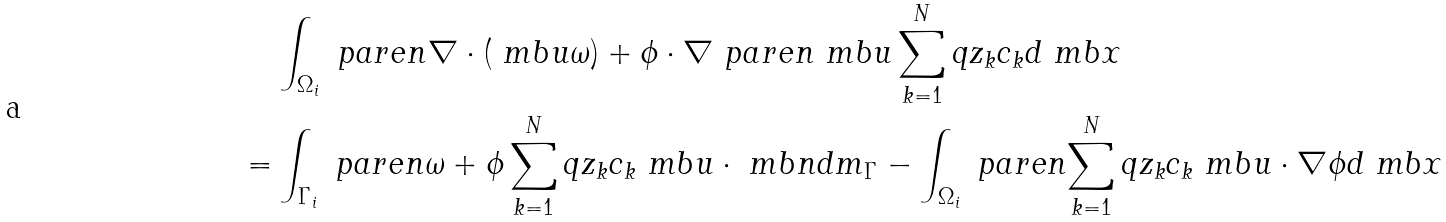<formula> <loc_0><loc_0><loc_500><loc_500>& \int _ { \Omega _ { i } } \ p a r e n { \nabla \cdot ( \ m b { u } \omega ) + \phi \cdot \nabla \ p a r e n { \ m b { u } \sum _ { k = 1 } ^ { N } q z _ { k } c _ { k } } } d \ m b { x } \\ = & \int _ { \Gamma _ { i } } \ p a r e n { \omega + \phi \sum _ { k = 1 } ^ { N } q z _ { k } c _ { k } } \ m b { u } \cdot \ m b { n } d m _ { \Gamma } - \int _ { \Omega _ { i } } \ p a r e n { \sum _ { k = 1 } ^ { N } q z _ { k } c _ { k } } \ m b { u } \cdot \nabla \phi d \ m b { x }</formula> 